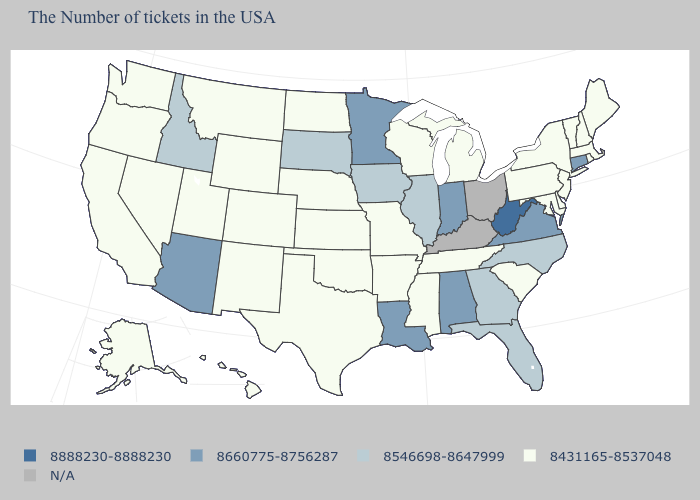Does North Dakota have the lowest value in the MidWest?
Give a very brief answer. Yes. Among the states that border Maryland , which have the highest value?
Give a very brief answer. West Virginia. What is the value of Oklahoma?
Keep it brief. 8431165-8537048. What is the value of Nevada?
Concise answer only. 8431165-8537048. Is the legend a continuous bar?
Write a very short answer. No. Which states have the highest value in the USA?
Keep it brief. West Virginia. What is the highest value in the West ?
Short answer required. 8660775-8756287. What is the lowest value in the South?
Write a very short answer. 8431165-8537048. What is the lowest value in the West?
Give a very brief answer. 8431165-8537048. Which states have the lowest value in the MidWest?
Answer briefly. Michigan, Wisconsin, Missouri, Kansas, Nebraska, North Dakota. Which states hav the highest value in the MidWest?
Give a very brief answer. Indiana, Minnesota. Name the states that have a value in the range 8888230-8888230?
Keep it brief. West Virginia. Among the states that border Colorado , which have the lowest value?
Answer briefly. Kansas, Nebraska, Oklahoma, Wyoming, New Mexico, Utah. Does Wisconsin have the highest value in the USA?
Give a very brief answer. No. What is the value of Vermont?
Short answer required. 8431165-8537048. 